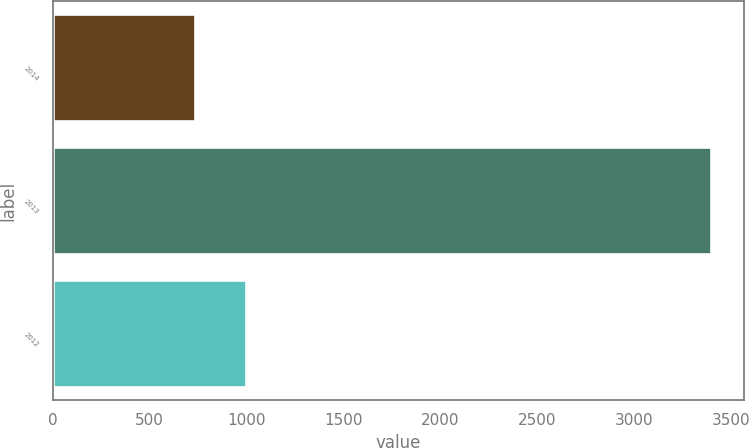Convert chart to OTSL. <chart><loc_0><loc_0><loc_500><loc_500><bar_chart><fcel>2014<fcel>2013<fcel>2012<nl><fcel>732<fcel>3399<fcel>998.7<nl></chart> 